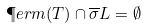Convert formula to latex. <formula><loc_0><loc_0><loc_500><loc_500>\P e r m ( T ) \cap \overline { \sigma } L = \emptyset</formula> 